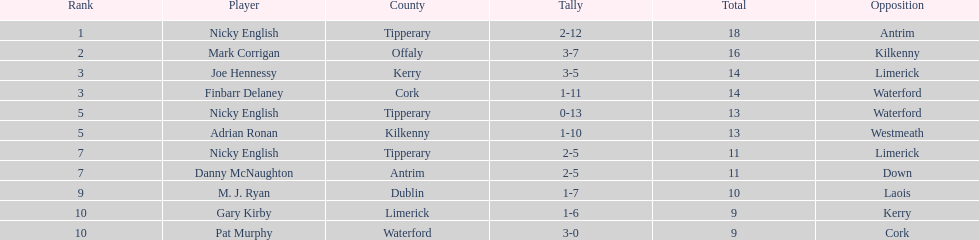What was the average of the totals of nicky english and mark corrigan? 17. 